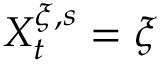<formula> <loc_0><loc_0><loc_500><loc_500>X _ { t } ^ { \xi , s } = \xi</formula> 